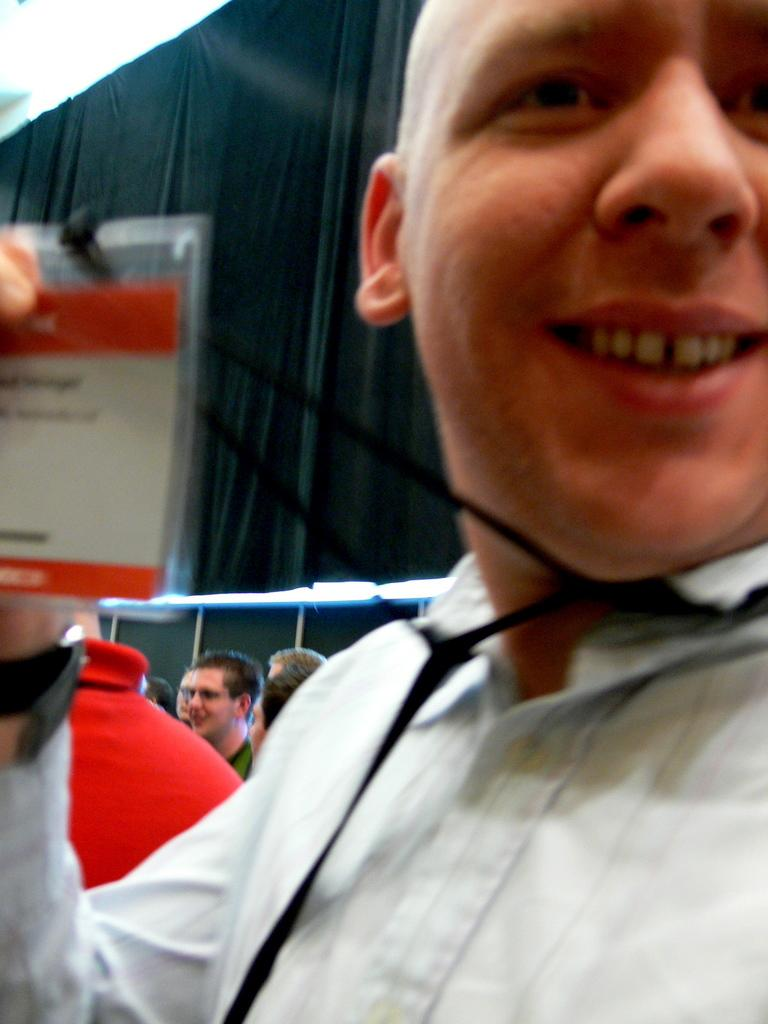Who is present in the image? There is a person in the image. What is the person doing in the image? The person is smiling in the image. Can you describe the surroundings of the person? There are a few people in the background of the image. What type of system is being used by the person in the image? There is no system visible in the image; it only shows a person smiling with a few people in the background. 